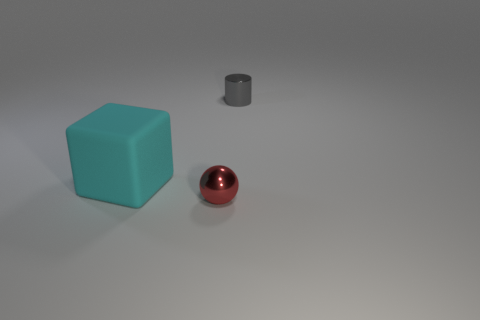Are there any other things that have the same shape as the tiny red metal object?
Provide a short and direct response. No. What number of things are yellow metallic blocks or small balls?
Give a very brief answer. 1. Does the small red object have the same shape as the tiny object that is behind the small red sphere?
Make the answer very short. No. The small object that is in front of the cyan object has what shape?
Ensure brevity in your answer.  Sphere. Is the size of the thing behind the cube the same as the big cyan matte object?
Provide a succinct answer. No. What is the size of the thing that is behind the small red thing and in front of the cylinder?
Provide a short and direct response. Large. Is the number of small red objects that are behind the tiny gray cylinder the same as the number of big yellow cylinders?
Your answer should be compact. Yes. The small cylinder has what color?
Provide a short and direct response. Gray. What is the color of the tiny object that is the same material as the cylinder?
Provide a short and direct response. Red. Are there any balls that have the same size as the cylinder?
Offer a terse response. Yes. 